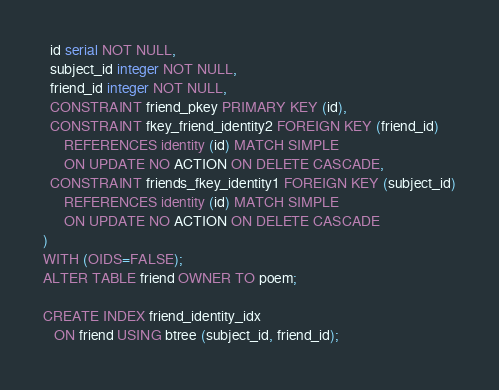<code> <loc_0><loc_0><loc_500><loc_500><_SQL_>  id serial NOT NULL,
  subject_id integer NOT NULL,
  friend_id integer NOT NULL,
  CONSTRAINT friend_pkey PRIMARY KEY (id),
  CONSTRAINT fkey_friend_identity2 FOREIGN KEY (friend_id)
      REFERENCES identity (id) MATCH SIMPLE
      ON UPDATE NO ACTION ON DELETE CASCADE,
  CONSTRAINT friends_fkey_identity1 FOREIGN KEY (subject_id)
      REFERENCES identity (id) MATCH SIMPLE
      ON UPDATE NO ACTION ON DELETE CASCADE
)
WITH (OIDS=FALSE);
ALTER TABLE friend OWNER TO poem;

CREATE INDEX friend_identity_idx
   ON friend USING btree (subject_id, friend_id);</code> 